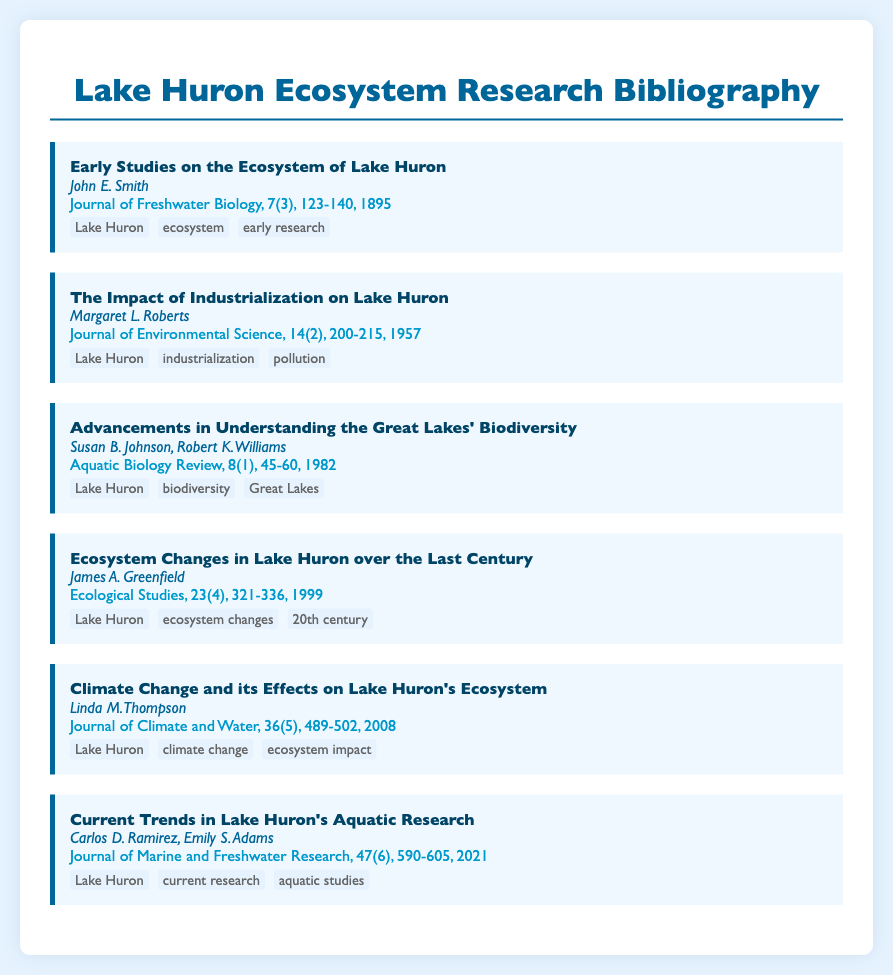What is the title of the first study listed? The title of the first study in the bibliography is "Early Studies on the Ecosystem of Lake Huron."
Answer: Early Studies on the Ecosystem of Lake Huron Who is the author of the article discussing industrialization? The author of the article titled "The Impact of Industrialization on Lake Huron" is Margaret L. Roberts.
Answer: Margaret L. Roberts In what year was the study on climate change published? The study titled "Climate Change and its Effects on Lake Huron's Ecosystem" was published in 2008.
Answer: 2008 How many authors contributed to the article on biodiversity? The article "Advancements in Understanding the Great Lakes' Biodiversity" has two authors, Susan B. Johnson and Robert K. Williams.
Answer: Two What is the focus of the most recent study listed? The most recent study, "Current Trends in Lake Huron's Aquatic Research," focuses on current research in aquatic studies.
Answer: Current research in aquatic studies Which journal published the article about ecosystem changes in 1999? The journal that published "Ecosystem Changes in Lake Huron over the Last Century" in 1999 is Ecological Studies.
Answer: Ecological Studies What are the keywords associated with the article by James A. Greenfield? The keywords associated with James A. Greenfield's study are Lake Huron, ecosystem changes, and 20th century.
Answer: Lake Huron, ecosystem changes, 20th century What type of document is this bibliographic entry? This is a bibliography, which lists various studies and research related to the ecosystem of Lake Huron.
Answer: Bibliography 